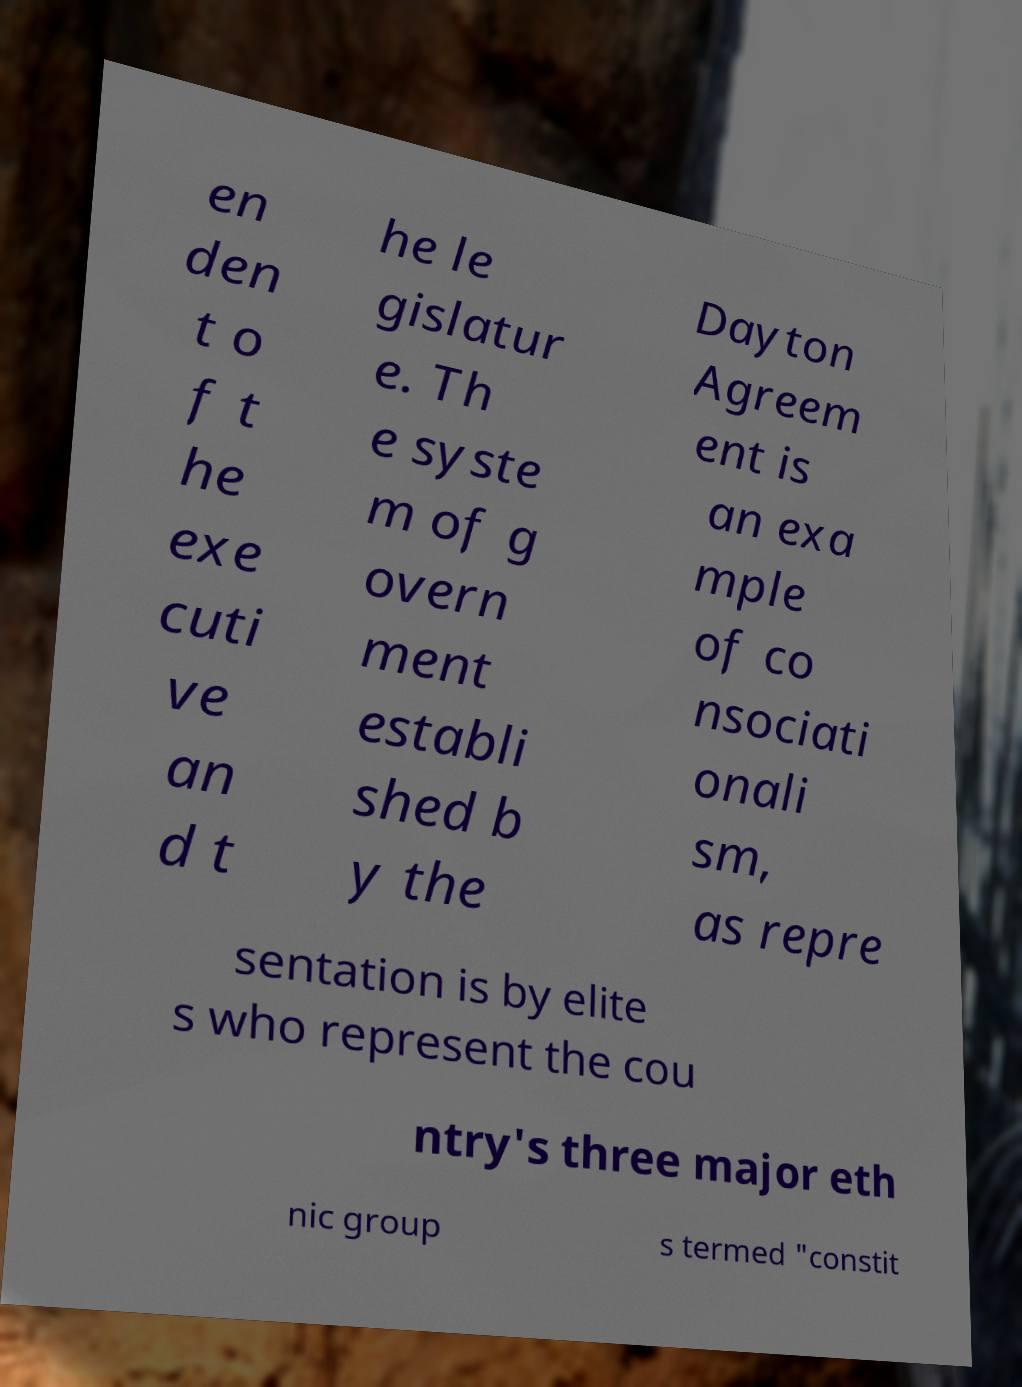Can you read and provide the text displayed in the image?This photo seems to have some interesting text. Can you extract and type it out for me? en den t o f t he exe cuti ve an d t he le gislatur e. Th e syste m of g overn ment establi shed b y the Dayton Agreem ent is an exa mple of co nsociati onali sm, as repre sentation is by elite s who represent the cou ntry's three major eth nic group s termed "constit 